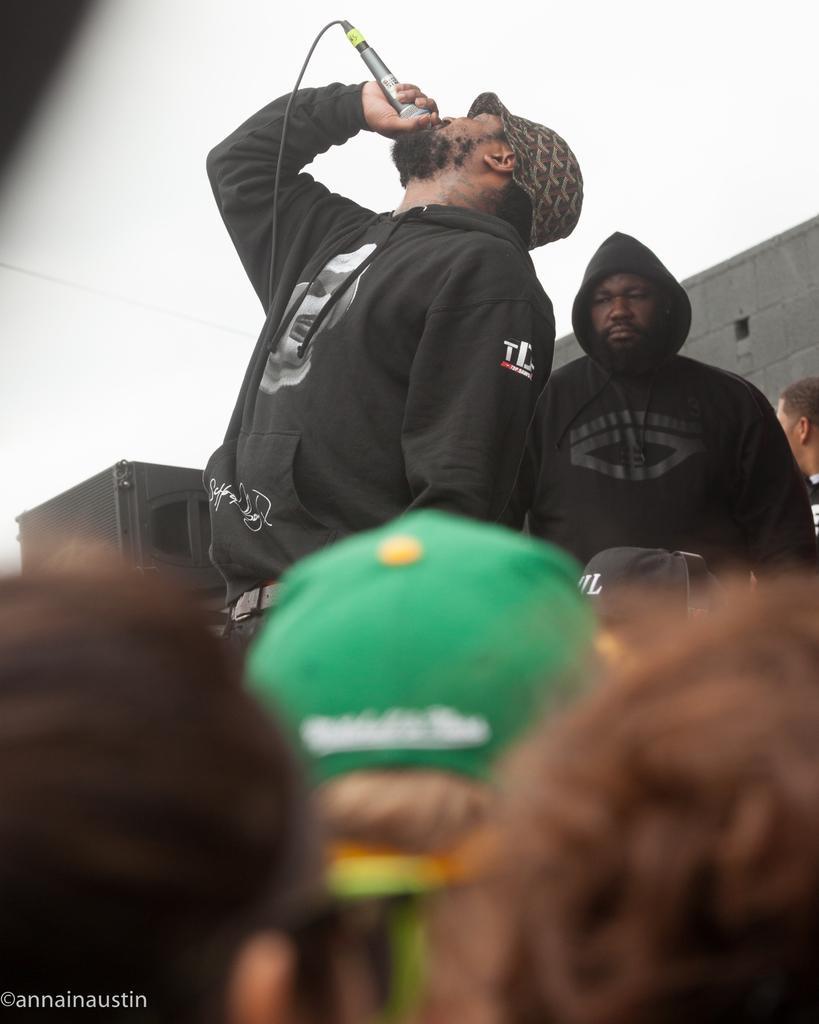Can you describe this image briefly? In this image we can see a few people, one of them is holding a mic, he is singing, also we can see the wall, and the sky. 